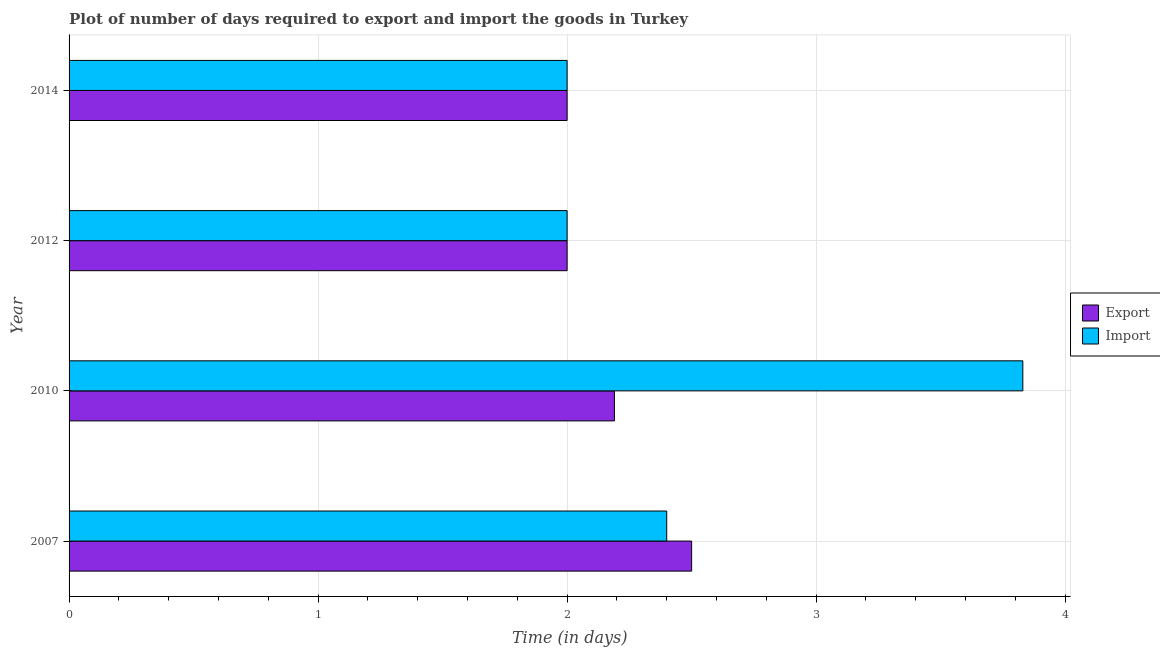How many different coloured bars are there?
Your response must be concise. 2. Are the number of bars per tick equal to the number of legend labels?
Offer a very short reply. Yes. How many bars are there on the 4th tick from the bottom?
Offer a very short reply. 2. What is the label of the 3rd group of bars from the top?
Provide a short and direct response. 2010. In how many cases, is the number of bars for a given year not equal to the number of legend labels?
Offer a terse response. 0. Across all years, what is the minimum time required to export?
Offer a very short reply. 2. In which year was the time required to export minimum?
Ensure brevity in your answer.  2012. What is the total time required to import in the graph?
Make the answer very short. 10.23. What is the difference between the time required to export in 2010 and the time required to import in 2012?
Offer a very short reply. 0.19. What is the average time required to export per year?
Keep it short and to the point. 2.17. In the year 2007, what is the difference between the time required to export and time required to import?
Offer a terse response. 0.1. In how many years, is the time required to import greater than 0.8 days?
Keep it short and to the point. 4. What is the ratio of the time required to import in 2010 to that in 2014?
Provide a short and direct response. 1.92. Is the time required to export in 2007 less than that in 2014?
Your response must be concise. No. What is the difference between the highest and the second highest time required to export?
Make the answer very short. 0.31. In how many years, is the time required to import greater than the average time required to import taken over all years?
Give a very brief answer. 1. Is the sum of the time required to export in 2010 and 2012 greater than the maximum time required to import across all years?
Your answer should be very brief. Yes. What does the 2nd bar from the top in 2014 represents?
Make the answer very short. Export. What does the 1st bar from the bottom in 2014 represents?
Your answer should be compact. Export. How many bars are there?
Provide a short and direct response. 8. Are all the bars in the graph horizontal?
Give a very brief answer. Yes. Are the values on the major ticks of X-axis written in scientific E-notation?
Your answer should be very brief. No. Does the graph contain any zero values?
Offer a terse response. No. Does the graph contain grids?
Provide a short and direct response. Yes. Where does the legend appear in the graph?
Your answer should be very brief. Center right. How many legend labels are there?
Your answer should be compact. 2. What is the title of the graph?
Provide a short and direct response. Plot of number of days required to export and import the goods in Turkey. What is the label or title of the X-axis?
Offer a very short reply. Time (in days). What is the label or title of the Y-axis?
Your answer should be compact. Year. What is the Time (in days) in Export in 2007?
Ensure brevity in your answer.  2.5. What is the Time (in days) in Export in 2010?
Your response must be concise. 2.19. What is the Time (in days) in Import in 2010?
Provide a succinct answer. 3.83. What is the Time (in days) of Import in 2014?
Your response must be concise. 2. Across all years, what is the maximum Time (in days) of Import?
Provide a short and direct response. 3.83. Across all years, what is the minimum Time (in days) in Import?
Your answer should be very brief. 2. What is the total Time (in days) of Export in the graph?
Provide a short and direct response. 8.69. What is the total Time (in days) of Import in the graph?
Offer a terse response. 10.23. What is the difference between the Time (in days) in Export in 2007 and that in 2010?
Your response must be concise. 0.31. What is the difference between the Time (in days) in Import in 2007 and that in 2010?
Your answer should be very brief. -1.43. What is the difference between the Time (in days) of Export in 2007 and that in 2012?
Offer a terse response. 0.5. What is the difference between the Time (in days) in Import in 2007 and that in 2012?
Offer a terse response. 0.4. What is the difference between the Time (in days) in Export in 2010 and that in 2012?
Your response must be concise. 0.19. What is the difference between the Time (in days) of Import in 2010 and that in 2012?
Your answer should be very brief. 1.83. What is the difference between the Time (in days) in Export in 2010 and that in 2014?
Provide a short and direct response. 0.19. What is the difference between the Time (in days) of Import in 2010 and that in 2014?
Offer a very short reply. 1.83. What is the difference between the Time (in days) in Export in 2012 and that in 2014?
Offer a terse response. 0. What is the difference between the Time (in days) of Export in 2007 and the Time (in days) of Import in 2010?
Your response must be concise. -1.33. What is the difference between the Time (in days) of Export in 2007 and the Time (in days) of Import in 2014?
Keep it short and to the point. 0.5. What is the difference between the Time (in days) in Export in 2010 and the Time (in days) in Import in 2012?
Provide a succinct answer. 0.19. What is the difference between the Time (in days) in Export in 2010 and the Time (in days) in Import in 2014?
Your answer should be compact. 0.19. What is the average Time (in days) in Export per year?
Your answer should be compact. 2.17. What is the average Time (in days) in Import per year?
Your answer should be very brief. 2.56. In the year 2010, what is the difference between the Time (in days) in Export and Time (in days) in Import?
Give a very brief answer. -1.64. In the year 2014, what is the difference between the Time (in days) of Export and Time (in days) of Import?
Offer a terse response. 0. What is the ratio of the Time (in days) in Export in 2007 to that in 2010?
Keep it short and to the point. 1.14. What is the ratio of the Time (in days) in Import in 2007 to that in 2010?
Provide a succinct answer. 0.63. What is the ratio of the Time (in days) in Import in 2007 to that in 2012?
Your answer should be very brief. 1.2. What is the ratio of the Time (in days) of Export in 2007 to that in 2014?
Your response must be concise. 1.25. What is the ratio of the Time (in days) in Import in 2007 to that in 2014?
Your response must be concise. 1.2. What is the ratio of the Time (in days) of Export in 2010 to that in 2012?
Offer a very short reply. 1.09. What is the ratio of the Time (in days) of Import in 2010 to that in 2012?
Your answer should be compact. 1.92. What is the ratio of the Time (in days) in Export in 2010 to that in 2014?
Ensure brevity in your answer.  1.09. What is the ratio of the Time (in days) of Import in 2010 to that in 2014?
Make the answer very short. 1.92. What is the ratio of the Time (in days) in Import in 2012 to that in 2014?
Your answer should be very brief. 1. What is the difference between the highest and the second highest Time (in days) in Export?
Provide a succinct answer. 0.31. What is the difference between the highest and the second highest Time (in days) in Import?
Provide a succinct answer. 1.43. What is the difference between the highest and the lowest Time (in days) in Import?
Offer a very short reply. 1.83. 